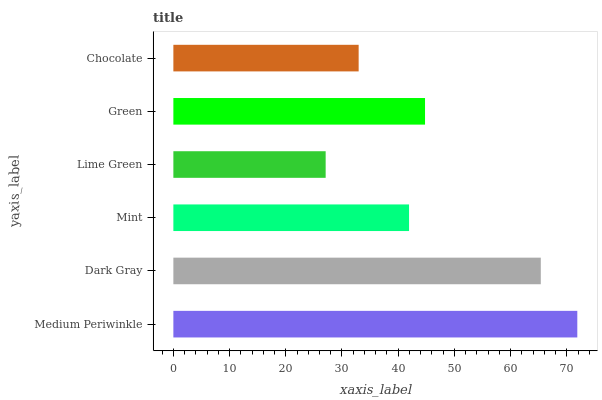Is Lime Green the minimum?
Answer yes or no. Yes. Is Medium Periwinkle the maximum?
Answer yes or no. Yes. Is Dark Gray the minimum?
Answer yes or no. No. Is Dark Gray the maximum?
Answer yes or no. No. Is Medium Periwinkle greater than Dark Gray?
Answer yes or no. Yes. Is Dark Gray less than Medium Periwinkle?
Answer yes or no. Yes. Is Dark Gray greater than Medium Periwinkle?
Answer yes or no. No. Is Medium Periwinkle less than Dark Gray?
Answer yes or no. No. Is Green the high median?
Answer yes or no. Yes. Is Mint the low median?
Answer yes or no. Yes. Is Dark Gray the high median?
Answer yes or no. No. Is Chocolate the low median?
Answer yes or no. No. 